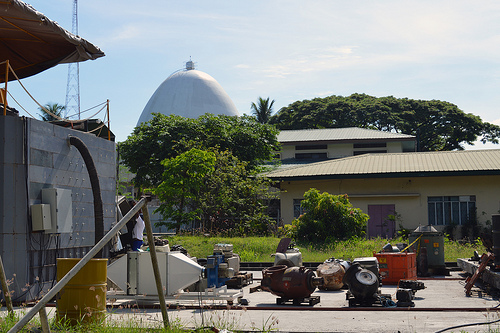<image>
Is the tree on the building? No. The tree is not positioned on the building. They may be near each other, but the tree is not supported by or resting on top of the building. 